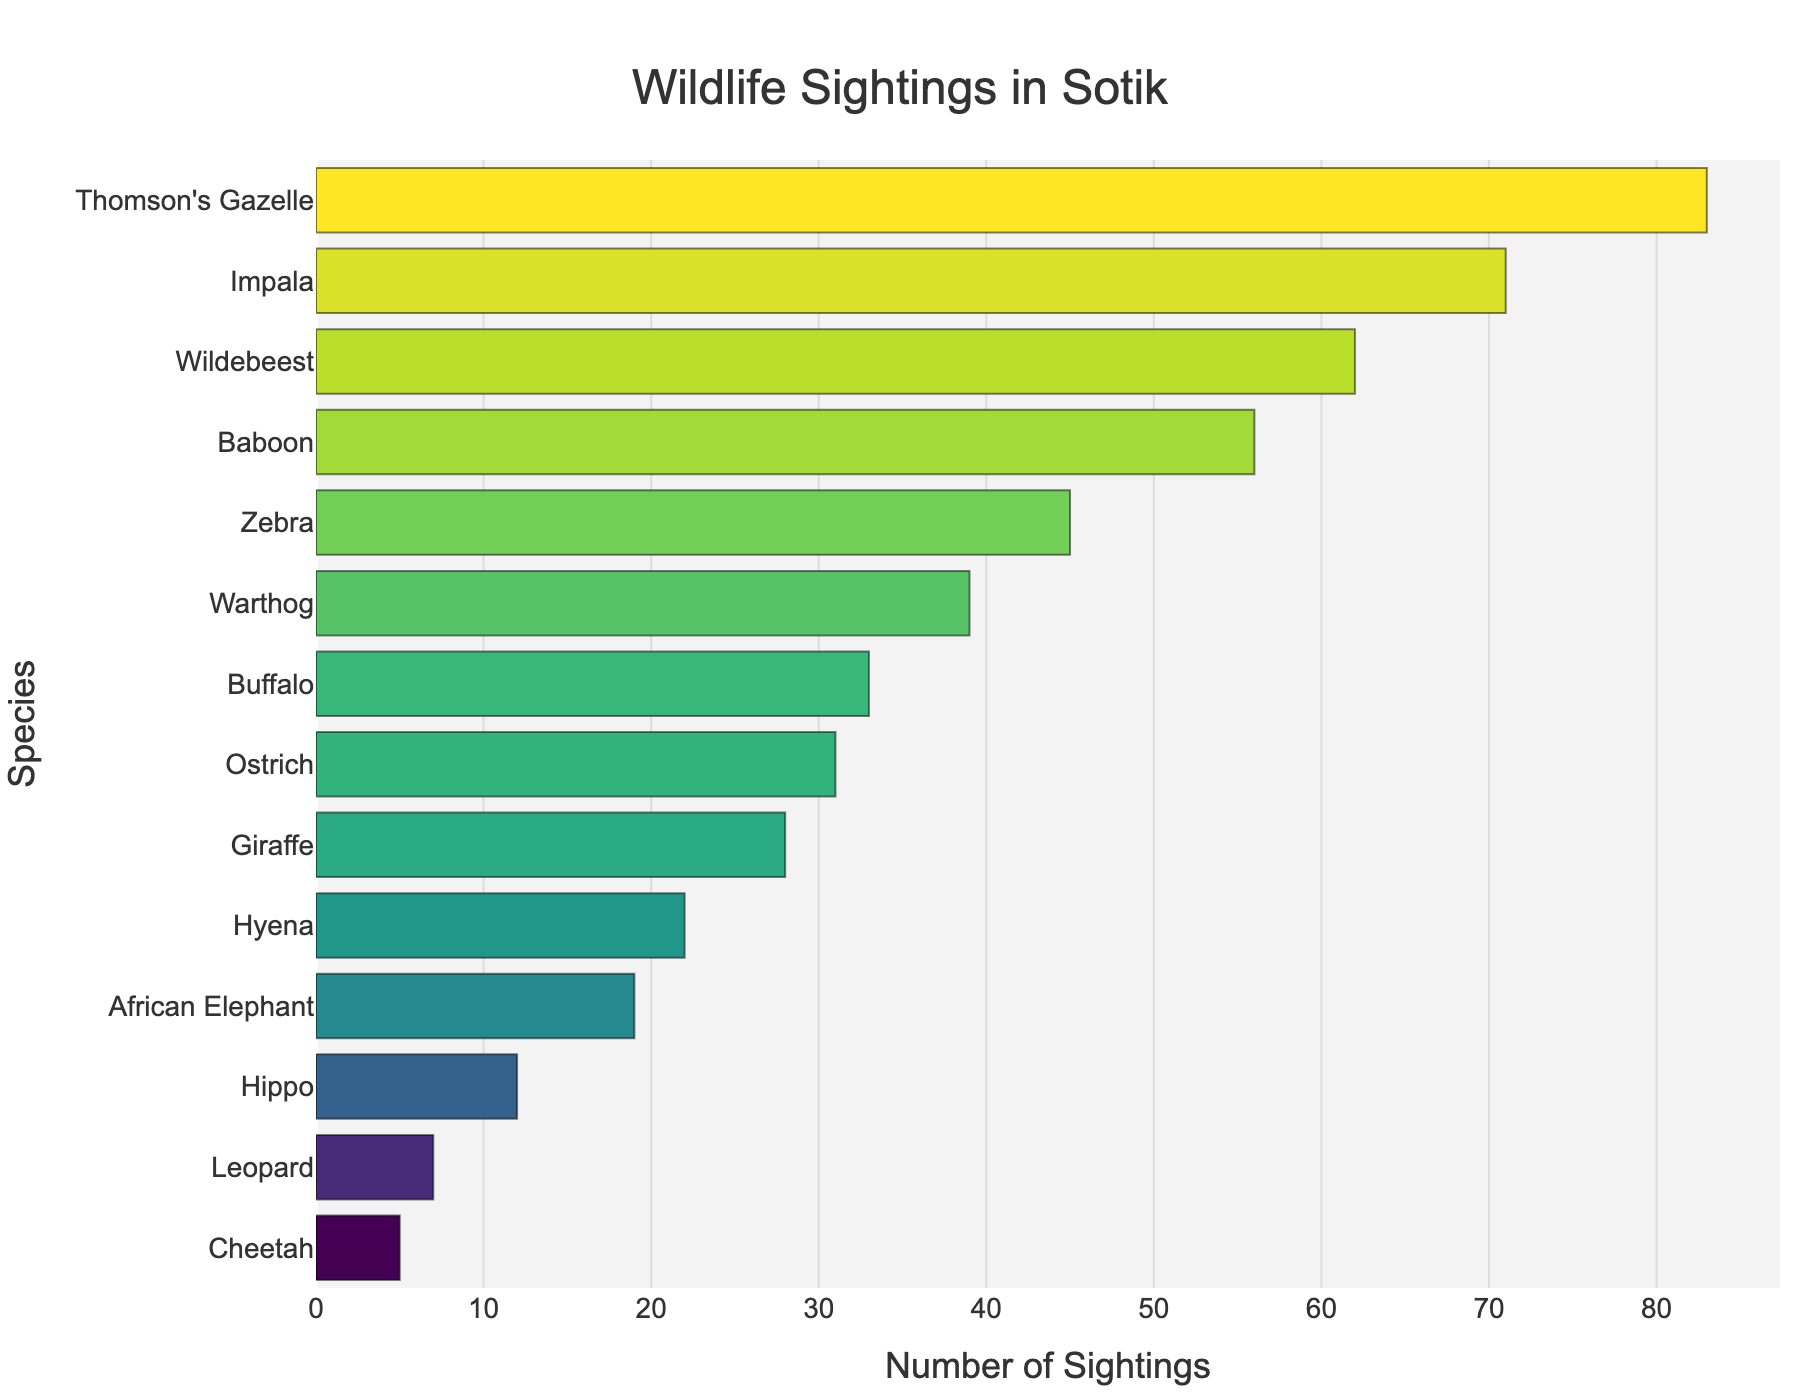Which species has the highest number of sightings? The figure shows different species on the y-axis and their respective sightings on the x-axis. Thomson's Gazelle has the longest bar, indicating the most sightings.
Answer: Thomson's Gazelle What is the total number of sightings for Zebras and Giraffes? From the figure, the sightings for Zebras are 45 and for Giraffes are 28. Summing these values, we get 45 + 28 = 73.
Answer: 73 Which species has fewer sightings, Hyenas or Hippos? In the plot, the bar for Hippos is shorter than the bar for Hyenas. This means Hippos have fewer sightings.
Answer: Hippos What's the average number of sightings for Buffalo and Ostrich? The figure indicates Buffalo has 33 sightings and Ostrich has 31 sightings. The average is calculated as (33 + 31) / 2 = 32.
Answer: 32 What is the ratio of sightings between the species with the most sightings and the species with the least sightings? Thomson's Gazelle has the most sightings (83) and Cheetah has the least sightings (5). The ratio is 83 / 5 = 16.6.
Answer: 16.6 What species are in the top three for number of sightings? The three longest bars in the plot correspond to Thomson's Gazelle, Impala, and Wildebeest, indicating these species have the highest sightings.
Answer: Thomson's Gazelle, Impala, Wildebeest How many species have more than 50 sightings? From the plot, the species with more than 50 sightings are Thomson's Gazelle, Impala, Wildebeest, and Baboon. This makes a total of 4 species.
Answer: 4 Which has more sightings, Warthogs or Baboons, and by how much? The figure shows Baboons have 56 sightings, and Warthogs have 39. The difference is 56 - 39 = 17.
Answer: Baboons by 17 Is the number of sightings for African Elephants between those for Giraffes and Buffalo? The figure shows that Giraffes have 28 sightings, African Elephants have 19, and Buffalo have 33. Thus, 19 is between 28 and 33.
Answer: Yes What is the sum of the sightings for species with less than 20 sightings? From the figure, the species with fewer than 20 sightings are African Elephant (19), Hippo (12), Leopard (7), and Cheetah (5). The sum is 19 + 12 + 7 + 5 = 43.
Answer: 43 